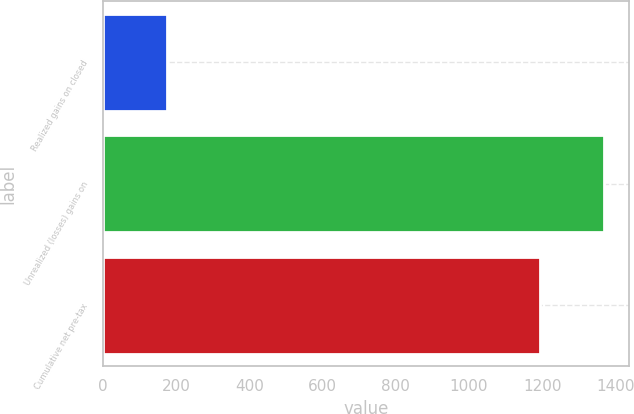Convert chart to OTSL. <chart><loc_0><loc_0><loc_500><loc_500><bar_chart><fcel>Realized gains on closed<fcel>Unrealized (losses) gains on<fcel>Cumulative net pre-tax<nl><fcel>174<fcel>1369<fcel>1195<nl></chart> 